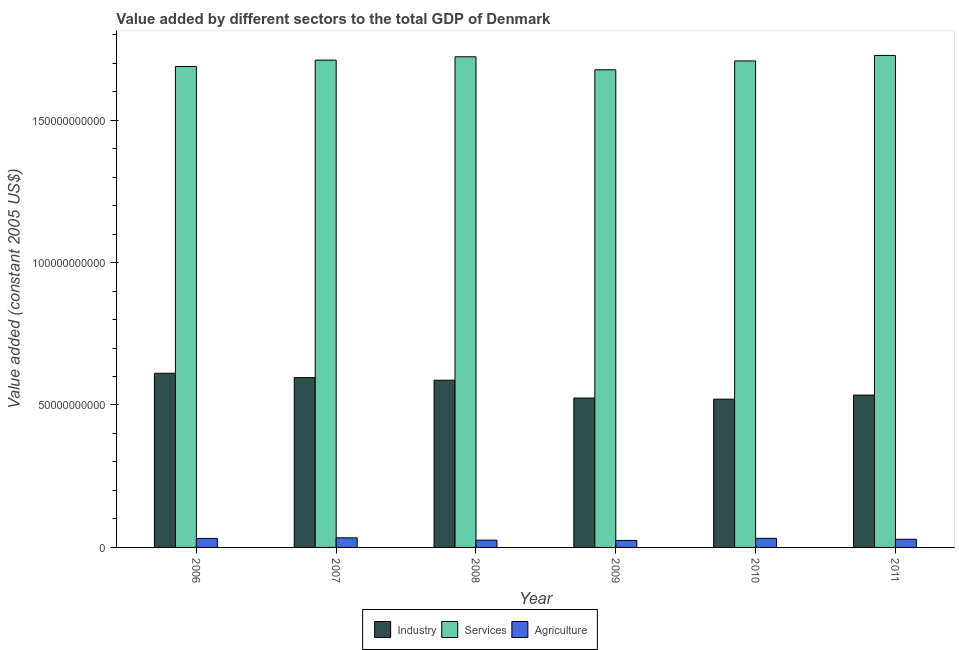How many different coloured bars are there?
Provide a short and direct response. 3. Are the number of bars per tick equal to the number of legend labels?
Offer a terse response. Yes. Are the number of bars on each tick of the X-axis equal?
Your answer should be very brief. Yes. How many bars are there on the 6th tick from the left?
Offer a terse response. 3. How many bars are there on the 6th tick from the right?
Keep it short and to the point. 3. What is the label of the 2nd group of bars from the left?
Make the answer very short. 2007. What is the value added by agricultural sector in 2011?
Keep it short and to the point. 2.87e+09. Across all years, what is the maximum value added by industrial sector?
Offer a terse response. 6.11e+1. Across all years, what is the minimum value added by services?
Offer a very short reply. 1.68e+11. In which year was the value added by industrial sector maximum?
Your response must be concise. 2006. What is the total value added by services in the graph?
Your answer should be compact. 1.02e+12. What is the difference between the value added by services in 2008 and that in 2010?
Give a very brief answer. 1.45e+09. What is the difference between the value added by services in 2007 and the value added by industrial sector in 2011?
Keep it short and to the point. -1.65e+09. What is the average value added by services per year?
Provide a short and direct response. 1.71e+11. In the year 2006, what is the difference between the value added by services and value added by agricultural sector?
Keep it short and to the point. 0. What is the ratio of the value added by industrial sector in 2009 to that in 2011?
Give a very brief answer. 0.98. What is the difference between the highest and the second highest value added by industrial sector?
Offer a very short reply. 1.52e+09. What is the difference between the highest and the lowest value added by industrial sector?
Offer a terse response. 9.08e+09. Is the sum of the value added by industrial sector in 2006 and 2007 greater than the maximum value added by services across all years?
Your answer should be compact. Yes. What does the 1st bar from the left in 2008 represents?
Ensure brevity in your answer.  Industry. What does the 1st bar from the right in 2007 represents?
Offer a very short reply. Agriculture. Are the values on the major ticks of Y-axis written in scientific E-notation?
Offer a terse response. No. Where does the legend appear in the graph?
Your answer should be compact. Bottom center. How many legend labels are there?
Your answer should be compact. 3. What is the title of the graph?
Provide a short and direct response. Value added by different sectors to the total GDP of Denmark. What is the label or title of the X-axis?
Provide a succinct answer. Year. What is the label or title of the Y-axis?
Keep it short and to the point. Value added (constant 2005 US$). What is the Value added (constant 2005 US$) of Industry in 2006?
Ensure brevity in your answer.  6.11e+1. What is the Value added (constant 2005 US$) of Services in 2006?
Give a very brief answer. 1.69e+11. What is the Value added (constant 2005 US$) of Agriculture in 2006?
Offer a very short reply. 3.16e+09. What is the Value added (constant 2005 US$) in Industry in 2007?
Keep it short and to the point. 5.96e+1. What is the Value added (constant 2005 US$) in Services in 2007?
Make the answer very short. 1.71e+11. What is the Value added (constant 2005 US$) of Agriculture in 2007?
Offer a terse response. 3.37e+09. What is the Value added (constant 2005 US$) of Industry in 2008?
Keep it short and to the point. 5.87e+1. What is the Value added (constant 2005 US$) in Services in 2008?
Your response must be concise. 1.72e+11. What is the Value added (constant 2005 US$) of Agriculture in 2008?
Give a very brief answer. 2.54e+09. What is the Value added (constant 2005 US$) in Industry in 2009?
Give a very brief answer. 5.24e+1. What is the Value added (constant 2005 US$) of Services in 2009?
Keep it short and to the point. 1.68e+11. What is the Value added (constant 2005 US$) in Agriculture in 2009?
Ensure brevity in your answer.  2.46e+09. What is the Value added (constant 2005 US$) of Industry in 2010?
Your answer should be compact. 5.21e+1. What is the Value added (constant 2005 US$) in Services in 2010?
Offer a terse response. 1.71e+11. What is the Value added (constant 2005 US$) in Agriculture in 2010?
Provide a short and direct response. 3.20e+09. What is the Value added (constant 2005 US$) of Industry in 2011?
Your answer should be compact. 5.35e+1. What is the Value added (constant 2005 US$) in Services in 2011?
Ensure brevity in your answer.  1.73e+11. What is the Value added (constant 2005 US$) of Agriculture in 2011?
Offer a terse response. 2.87e+09. Across all years, what is the maximum Value added (constant 2005 US$) of Industry?
Your answer should be compact. 6.11e+1. Across all years, what is the maximum Value added (constant 2005 US$) of Services?
Provide a short and direct response. 1.73e+11. Across all years, what is the maximum Value added (constant 2005 US$) in Agriculture?
Ensure brevity in your answer.  3.37e+09. Across all years, what is the minimum Value added (constant 2005 US$) in Industry?
Provide a succinct answer. 5.21e+1. Across all years, what is the minimum Value added (constant 2005 US$) of Services?
Ensure brevity in your answer.  1.68e+11. Across all years, what is the minimum Value added (constant 2005 US$) in Agriculture?
Your answer should be very brief. 2.46e+09. What is the total Value added (constant 2005 US$) of Industry in the graph?
Ensure brevity in your answer.  3.37e+11. What is the total Value added (constant 2005 US$) of Services in the graph?
Your answer should be very brief. 1.02e+12. What is the total Value added (constant 2005 US$) of Agriculture in the graph?
Offer a very short reply. 1.76e+1. What is the difference between the Value added (constant 2005 US$) in Industry in 2006 and that in 2007?
Your answer should be very brief. 1.52e+09. What is the difference between the Value added (constant 2005 US$) in Services in 2006 and that in 2007?
Make the answer very short. -2.23e+09. What is the difference between the Value added (constant 2005 US$) in Agriculture in 2006 and that in 2007?
Provide a succinct answer. -2.03e+08. What is the difference between the Value added (constant 2005 US$) in Industry in 2006 and that in 2008?
Your response must be concise. 2.44e+09. What is the difference between the Value added (constant 2005 US$) in Services in 2006 and that in 2008?
Your response must be concise. -3.40e+09. What is the difference between the Value added (constant 2005 US$) in Agriculture in 2006 and that in 2008?
Ensure brevity in your answer.  6.19e+08. What is the difference between the Value added (constant 2005 US$) of Industry in 2006 and that in 2009?
Your response must be concise. 8.69e+09. What is the difference between the Value added (constant 2005 US$) of Services in 2006 and that in 2009?
Your answer should be very brief. 1.16e+09. What is the difference between the Value added (constant 2005 US$) of Agriculture in 2006 and that in 2009?
Your answer should be very brief. 7.05e+08. What is the difference between the Value added (constant 2005 US$) of Industry in 2006 and that in 2010?
Keep it short and to the point. 9.08e+09. What is the difference between the Value added (constant 2005 US$) in Services in 2006 and that in 2010?
Your answer should be very brief. -1.96e+09. What is the difference between the Value added (constant 2005 US$) in Agriculture in 2006 and that in 2010?
Your answer should be very brief. -3.84e+07. What is the difference between the Value added (constant 2005 US$) of Industry in 2006 and that in 2011?
Offer a very short reply. 7.66e+09. What is the difference between the Value added (constant 2005 US$) in Services in 2006 and that in 2011?
Your answer should be very brief. -3.88e+09. What is the difference between the Value added (constant 2005 US$) of Agriculture in 2006 and that in 2011?
Keep it short and to the point. 2.90e+08. What is the difference between the Value added (constant 2005 US$) in Industry in 2007 and that in 2008?
Give a very brief answer. 9.13e+08. What is the difference between the Value added (constant 2005 US$) in Services in 2007 and that in 2008?
Your answer should be very brief. -1.17e+09. What is the difference between the Value added (constant 2005 US$) of Agriculture in 2007 and that in 2008?
Offer a very short reply. 8.22e+08. What is the difference between the Value added (constant 2005 US$) of Industry in 2007 and that in 2009?
Your answer should be compact. 7.17e+09. What is the difference between the Value added (constant 2005 US$) in Services in 2007 and that in 2009?
Provide a short and direct response. 3.39e+09. What is the difference between the Value added (constant 2005 US$) of Agriculture in 2007 and that in 2009?
Offer a very short reply. 9.08e+08. What is the difference between the Value added (constant 2005 US$) in Industry in 2007 and that in 2010?
Your answer should be very brief. 7.56e+09. What is the difference between the Value added (constant 2005 US$) of Services in 2007 and that in 2010?
Ensure brevity in your answer.  2.75e+08. What is the difference between the Value added (constant 2005 US$) in Agriculture in 2007 and that in 2010?
Your answer should be very brief. 1.65e+08. What is the difference between the Value added (constant 2005 US$) of Industry in 2007 and that in 2011?
Offer a terse response. 6.13e+09. What is the difference between the Value added (constant 2005 US$) of Services in 2007 and that in 2011?
Give a very brief answer. -1.65e+09. What is the difference between the Value added (constant 2005 US$) in Agriculture in 2007 and that in 2011?
Your answer should be very brief. 4.93e+08. What is the difference between the Value added (constant 2005 US$) of Industry in 2008 and that in 2009?
Offer a very short reply. 6.25e+09. What is the difference between the Value added (constant 2005 US$) of Services in 2008 and that in 2009?
Make the answer very short. 4.57e+09. What is the difference between the Value added (constant 2005 US$) in Agriculture in 2008 and that in 2009?
Provide a short and direct response. 8.63e+07. What is the difference between the Value added (constant 2005 US$) of Industry in 2008 and that in 2010?
Provide a succinct answer. 6.65e+09. What is the difference between the Value added (constant 2005 US$) in Services in 2008 and that in 2010?
Ensure brevity in your answer.  1.45e+09. What is the difference between the Value added (constant 2005 US$) of Agriculture in 2008 and that in 2010?
Offer a terse response. -6.57e+08. What is the difference between the Value added (constant 2005 US$) in Industry in 2008 and that in 2011?
Your response must be concise. 5.22e+09. What is the difference between the Value added (constant 2005 US$) of Services in 2008 and that in 2011?
Your response must be concise. -4.80e+08. What is the difference between the Value added (constant 2005 US$) of Agriculture in 2008 and that in 2011?
Offer a very short reply. -3.29e+08. What is the difference between the Value added (constant 2005 US$) of Industry in 2009 and that in 2010?
Your response must be concise. 3.93e+08. What is the difference between the Value added (constant 2005 US$) in Services in 2009 and that in 2010?
Your response must be concise. -3.12e+09. What is the difference between the Value added (constant 2005 US$) in Agriculture in 2009 and that in 2010?
Your answer should be compact. -7.44e+08. What is the difference between the Value added (constant 2005 US$) in Industry in 2009 and that in 2011?
Provide a succinct answer. -1.04e+09. What is the difference between the Value added (constant 2005 US$) of Services in 2009 and that in 2011?
Ensure brevity in your answer.  -5.04e+09. What is the difference between the Value added (constant 2005 US$) in Agriculture in 2009 and that in 2011?
Give a very brief answer. -4.15e+08. What is the difference between the Value added (constant 2005 US$) in Industry in 2010 and that in 2011?
Offer a terse response. -1.43e+09. What is the difference between the Value added (constant 2005 US$) in Services in 2010 and that in 2011?
Give a very brief answer. -1.93e+09. What is the difference between the Value added (constant 2005 US$) in Agriculture in 2010 and that in 2011?
Your answer should be compact. 3.29e+08. What is the difference between the Value added (constant 2005 US$) of Industry in 2006 and the Value added (constant 2005 US$) of Services in 2007?
Provide a short and direct response. -1.10e+11. What is the difference between the Value added (constant 2005 US$) in Industry in 2006 and the Value added (constant 2005 US$) in Agriculture in 2007?
Offer a terse response. 5.78e+1. What is the difference between the Value added (constant 2005 US$) of Services in 2006 and the Value added (constant 2005 US$) of Agriculture in 2007?
Your response must be concise. 1.65e+11. What is the difference between the Value added (constant 2005 US$) in Industry in 2006 and the Value added (constant 2005 US$) in Services in 2008?
Make the answer very short. -1.11e+11. What is the difference between the Value added (constant 2005 US$) in Industry in 2006 and the Value added (constant 2005 US$) in Agriculture in 2008?
Provide a succinct answer. 5.86e+1. What is the difference between the Value added (constant 2005 US$) of Services in 2006 and the Value added (constant 2005 US$) of Agriculture in 2008?
Your answer should be compact. 1.66e+11. What is the difference between the Value added (constant 2005 US$) of Industry in 2006 and the Value added (constant 2005 US$) of Services in 2009?
Your answer should be very brief. -1.07e+11. What is the difference between the Value added (constant 2005 US$) in Industry in 2006 and the Value added (constant 2005 US$) in Agriculture in 2009?
Give a very brief answer. 5.87e+1. What is the difference between the Value added (constant 2005 US$) of Services in 2006 and the Value added (constant 2005 US$) of Agriculture in 2009?
Provide a succinct answer. 1.66e+11. What is the difference between the Value added (constant 2005 US$) in Industry in 2006 and the Value added (constant 2005 US$) in Services in 2010?
Make the answer very short. -1.10e+11. What is the difference between the Value added (constant 2005 US$) of Industry in 2006 and the Value added (constant 2005 US$) of Agriculture in 2010?
Provide a short and direct response. 5.79e+1. What is the difference between the Value added (constant 2005 US$) of Services in 2006 and the Value added (constant 2005 US$) of Agriculture in 2010?
Provide a short and direct response. 1.66e+11. What is the difference between the Value added (constant 2005 US$) in Industry in 2006 and the Value added (constant 2005 US$) in Services in 2011?
Your response must be concise. -1.12e+11. What is the difference between the Value added (constant 2005 US$) in Industry in 2006 and the Value added (constant 2005 US$) in Agriculture in 2011?
Provide a succinct answer. 5.83e+1. What is the difference between the Value added (constant 2005 US$) of Services in 2006 and the Value added (constant 2005 US$) of Agriculture in 2011?
Make the answer very short. 1.66e+11. What is the difference between the Value added (constant 2005 US$) in Industry in 2007 and the Value added (constant 2005 US$) in Services in 2008?
Offer a terse response. -1.13e+11. What is the difference between the Value added (constant 2005 US$) in Industry in 2007 and the Value added (constant 2005 US$) in Agriculture in 2008?
Your answer should be very brief. 5.71e+1. What is the difference between the Value added (constant 2005 US$) of Services in 2007 and the Value added (constant 2005 US$) of Agriculture in 2008?
Ensure brevity in your answer.  1.69e+11. What is the difference between the Value added (constant 2005 US$) in Industry in 2007 and the Value added (constant 2005 US$) in Services in 2009?
Provide a short and direct response. -1.08e+11. What is the difference between the Value added (constant 2005 US$) of Industry in 2007 and the Value added (constant 2005 US$) of Agriculture in 2009?
Provide a succinct answer. 5.72e+1. What is the difference between the Value added (constant 2005 US$) of Services in 2007 and the Value added (constant 2005 US$) of Agriculture in 2009?
Give a very brief answer. 1.69e+11. What is the difference between the Value added (constant 2005 US$) of Industry in 2007 and the Value added (constant 2005 US$) of Services in 2010?
Your answer should be very brief. -1.11e+11. What is the difference between the Value added (constant 2005 US$) of Industry in 2007 and the Value added (constant 2005 US$) of Agriculture in 2010?
Make the answer very short. 5.64e+1. What is the difference between the Value added (constant 2005 US$) of Services in 2007 and the Value added (constant 2005 US$) of Agriculture in 2010?
Your response must be concise. 1.68e+11. What is the difference between the Value added (constant 2005 US$) in Industry in 2007 and the Value added (constant 2005 US$) in Services in 2011?
Keep it short and to the point. -1.13e+11. What is the difference between the Value added (constant 2005 US$) in Industry in 2007 and the Value added (constant 2005 US$) in Agriculture in 2011?
Your answer should be compact. 5.67e+1. What is the difference between the Value added (constant 2005 US$) of Services in 2007 and the Value added (constant 2005 US$) of Agriculture in 2011?
Give a very brief answer. 1.68e+11. What is the difference between the Value added (constant 2005 US$) in Industry in 2008 and the Value added (constant 2005 US$) in Services in 2009?
Keep it short and to the point. -1.09e+11. What is the difference between the Value added (constant 2005 US$) in Industry in 2008 and the Value added (constant 2005 US$) in Agriculture in 2009?
Make the answer very short. 5.62e+1. What is the difference between the Value added (constant 2005 US$) in Services in 2008 and the Value added (constant 2005 US$) in Agriculture in 2009?
Provide a short and direct response. 1.70e+11. What is the difference between the Value added (constant 2005 US$) of Industry in 2008 and the Value added (constant 2005 US$) of Services in 2010?
Your response must be concise. -1.12e+11. What is the difference between the Value added (constant 2005 US$) in Industry in 2008 and the Value added (constant 2005 US$) in Agriculture in 2010?
Make the answer very short. 5.55e+1. What is the difference between the Value added (constant 2005 US$) in Services in 2008 and the Value added (constant 2005 US$) in Agriculture in 2010?
Provide a short and direct response. 1.69e+11. What is the difference between the Value added (constant 2005 US$) in Industry in 2008 and the Value added (constant 2005 US$) in Services in 2011?
Provide a succinct answer. -1.14e+11. What is the difference between the Value added (constant 2005 US$) of Industry in 2008 and the Value added (constant 2005 US$) of Agriculture in 2011?
Keep it short and to the point. 5.58e+1. What is the difference between the Value added (constant 2005 US$) of Services in 2008 and the Value added (constant 2005 US$) of Agriculture in 2011?
Your answer should be compact. 1.69e+11. What is the difference between the Value added (constant 2005 US$) of Industry in 2009 and the Value added (constant 2005 US$) of Services in 2010?
Your answer should be very brief. -1.18e+11. What is the difference between the Value added (constant 2005 US$) in Industry in 2009 and the Value added (constant 2005 US$) in Agriculture in 2010?
Your answer should be compact. 4.92e+1. What is the difference between the Value added (constant 2005 US$) in Services in 2009 and the Value added (constant 2005 US$) in Agriculture in 2010?
Provide a short and direct response. 1.64e+11. What is the difference between the Value added (constant 2005 US$) in Industry in 2009 and the Value added (constant 2005 US$) in Services in 2011?
Give a very brief answer. -1.20e+11. What is the difference between the Value added (constant 2005 US$) of Industry in 2009 and the Value added (constant 2005 US$) of Agriculture in 2011?
Your answer should be compact. 4.96e+1. What is the difference between the Value added (constant 2005 US$) in Services in 2009 and the Value added (constant 2005 US$) in Agriculture in 2011?
Give a very brief answer. 1.65e+11. What is the difference between the Value added (constant 2005 US$) of Industry in 2010 and the Value added (constant 2005 US$) of Services in 2011?
Give a very brief answer. -1.21e+11. What is the difference between the Value added (constant 2005 US$) of Industry in 2010 and the Value added (constant 2005 US$) of Agriculture in 2011?
Provide a short and direct response. 4.92e+1. What is the difference between the Value added (constant 2005 US$) in Services in 2010 and the Value added (constant 2005 US$) in Agriculture in 2011?
Ensure brevity in your answer.  1.68e+11. What is the average Value added (constant 2005 US$) in Industry per year?
Provide a succinct answer. 5.62e+1. What is the average Value added (constant 2005 US$) of Services per year?
Your response must be concise. 1.71e+11. What is the average Value added (constant 2005 US$) of Agriculture per year?
Give a very brief answer. 2.93e+09. In the year 2006, what is the difference between the Value added (constant 2005 US$) of Industry and Value added (constant 2005 US$) of Services?
Provide a short and direct response. -1.08e+11. In the year 2006, what is the difference between the Value added (constant 2005 US$) in Industry and Value added (constant 2005 US$) in Agriculture?
Provide a short and direct response. 5.80e+1. In the year 2006, what is the difference between the Value added (constant 2005 US$) in Services and Value added (constant 2005 US$) in Agriculture?
Your answer should be compact. 1.66e+11. In the year 2007, what is the difference between the Value added (constant 2005 US$) in Industry and Value added (constant 2005 US$) in Services?
Make the answer very short. -1.11e+11. In the year 2007, what is the difference between the Value added (constant 2005 US$) of Industry and Value added (constant 2005 US$) of Agriculture?
Your answer should be very brief. 5.62e+1. In the year 2007, what is the difference between the Value added (constant 2005 US$) of Services and Value added (constant 2005 US$) of Agriculture?
Offer a very short reply. 1.68e+11. In the year 2008, what is the difference between the Value added (constant 2005 US$) in Industry and Value added (constant 2005 US$) in Services?
Make the answer very short. -1.14e+11. In the year 2008, what is the difference between the Value added (constant 2005 US$) of Industry and Value added (constant 2005 US$) of Agriculture?
Provide a succinct answer. 5.62e+1. In the year 2008, what is the difference between the Value added (constant 2005 US$) of Services and Value added (constant 2005 US$) of Agriculture?
Provide a short and direct response. 1.70e+11. In the year 2009, what is the difference between the Value added (constant 2005 US$) in Industry and Value added (constant 2005 US$) in Services?
Your answer should be compact. -1.15e+11. In the year 2009, what is the difference between the Value added (constant 2005 US$) of Industry and Value added (constant 2005 US$) of Agriculture?
Offer a very short reply. 5.00e+1. In the year 2009, what is the difference between the Value added (constant 2005 US$) in Services and Value added (constant 2005 US$) in Agriculture?
Your answer should be very brief. 1.65e+11. In the year 2010, what is the difference between the Value added (constant 2005 US$) of Industry and Value added (constant 2005 US$) of Services?
Ensure brevity in your answer.  -1.19e+11. In the year 2010, what is the difference between the Value added (constant 2005 US$) of Industry and Value added (constant 2005 US$) of Agriculture?
Your answer should be very brief. 4.89e+1. In the year 2010, what is the difference between the Value added (constant 2005 US$) of Services and Value added (constant 2005 US$) of Agriculture?
Offer a very short reply. 1.68e+11. In the year 2011, what is the difference between the Value added (constant 2005 US$) of Industry and Value added (constant 2005 US$) of Services?
Provide a short and direct response. -1.19e+11. In the year 2011, what is the difference between the Value added (constant 2005 US$) in Industry and Value added (constant 2005 US$) in Agriculture?
Ensure brevity in your answer.  5.06e+1. In the year 2011, what is the difference between the Value added (constant 2005 US$) of Services and Value added (constant 2005 US$) of Agriculture?
Your response must be concise. 1.70e+11. What is the ratio of the Value added (constant 2005 US$) of Industry in 2006 to that in 2007?
Make the answer very short. 1.03. What is the ratio of the Value added (constant 2005 US$) of Agriculture in 2006 to that in 2007?
Ensure brevity in your answer.  0.94. What is the ratio of the Value added (constant 2005 US$) of Industry in 2006 to that in 2008?
Make the answer very short. 1.04. What is the ratio of the Value added (constant 2005 US$) of Services in 2006 to that in 2008?
Your response must be concise. 0.98. What is the ratio of the Value added (constant 2005 US$) in Agriculture in 2006 to that in 2008?
Your answer should be very brief. 1.24. What is the ratio of the Value added (constant 2005 US$) in Industry in 2006 to that in 2009?
Offer a terse response. 1.17. What is the ratio of the Value added (constant 2005 US$) in Agriculture in 2006 to that in 2009?
Ensure brevity in your answer.  1.29. What is the ratio of the Value added (constant 2005 US$) in Industry in 2006 to that in 2010?
Your answer should be very brief. 1.17. What is the ratio of the Value added (constant 2005 US$) of Services in 2006 to that in 2010?
Provide a succinct answer. 0.99. What is the ratio of the Value added (constant 2005 US$) in Agriculture in 2006 to that in 2010?
Give a very brief answer. 0.99. What is the ratio of the Value added (constant 2005 US$) in Industry in 2006 to that in 2011?
Offer a very short reply. 1.14. What is the ratio of the Value added (constant 2005 US$) of Services in 2006 to that in 2011?
Offer a very short reply. 0.98. What is the ratio of the Value added (constant 2005 US$) of Agriculture in 2006 to that in 2011?
Offer a terse response. 1.1. What is the ratio of the Value added (constant 2005 US$) of Industry in 2007 to that in 2008?
Make the answer very short. 1.02. What is the ratio of the Value added (constant 2005 US$) of Services in 2007 to that in 2008?
Make the answer very short. 0.99. What is the ratio of the Value added (constant 2005 US$) in Agriculture in 2007 to that in 2008?
Your answer should be very brief. 1.32. What is the ratio of the Value added (constant 2005 US$) of Industry in 2007 to that in 2009?
Give a very brief answer. 1.14. What is the ratio of the Value added (constant 2005 US$) in Services in 2007 to that in 2009?
Make the answer very short. 1.02. What is the ratio of the Value added (constant 2005 US$) of Agriculture in 2007 to that in 2009?
Provide a short and direct response. 1.37. What is the ratio of the Value added (constant 2005 US$) in Industry in 2007 to that in 2010?
Your response must be concise. 1.15. What is the ratio of the Value added (constant 2005 US$) of Agriculture in 2007 to that in 2010?
Your answer should be compact. 1.05. What is the ratio of the Value added (constant 2005 US$) in Industry in 2007 to that in 2011?
Make the answer very short. 1.11. What is the ratio of the Value added (constant 2005 US$) in Agriculture in 2007 to that in 2011?
Give a very brief answer. 1.17. What is the ratio of the Value added (constant 2005 US$) of Industry in 2008 to that in 2009?
Your answer should be compact. 1.12. What is the ratio of the Value added (constant 2005 US$) of Services in 2008 to that in 2009?
Keep it short and to the point. 1.03. What is the ratio of the Value added (constant 2005 US$) in Agriculture in 2008 to that in 2009?
Offer a very short reply. 1.04. What is the ratio of the Value added (constant 2005 US$) in Industry in 2008 to that in 2010?
Provide a short and direct response. 1.13. What is the ratio of the Value added (constant 2005 US$) of Services in 2008 to that in 2010?
Make the answer very short. 1.01. What is the ratio of the Value added (constant 2005 US$) of Agriculture in 2008 to that in 2010?
Give a very brief answer. 0.79. What is the ratio of the Value added (constant 2005 US$) in Industry in 2008 to that in 2011?
Your response must be concise. 1.1. What is the ratio of the Value added (constant 2005 US$) in Agriculture in 2008 to that in 2011?
Make the answer very short. 0.89. What is the ratio of the Value added (constant 2005 US$) of Industry in 2009 to that in 2010?
Offer a terse response. 1.01. What is the ratio of the Value added (constant 2005 US$) of Services in 2009 to that in 2010?
Offer a terse response. 0.98. What is the ratio of the Value added (constant 2005 US$) in Agriculture in 2009 to that in 2010?
Give a very brief answer. 0.77. What is the ratio of the Value added (constant 2005 US$) in Industry in 2009 to that in 2011?
Ensure brevity in your answer.  0.98. What is the ratio of the Value added (constant 2005 US$) in Services in 2009 to that in 2011?
Your response must be concise. 0.97. What is the ratio of the Value added (constant 2005 US$) of Agriculture in 2009 to that in 2011?
Provide a succinct answer. 0.86. What is the ratio of the Value added (constant 2005 US$) in Industry in 2010 to that in 2011?
Provide a short and direct response. 0.97. What is the ratio of the Value added (constant 2005 US$) in Services in 2010 to that in 2011?
Your answer should be compact. 0.99. What is the ratio of the Value added (constant 2005 US$) in Agriculture in 2010 to that in 2011?
Make the answer very short. 1.11. What is the difference between the highest and the second highest Value added (constant 2005 US$) in Industry?
Your answer should be compact. 1.52e+09. What is the difference between the highest and the second highest Value added (constant 2005 US$) of Services?
Your answer should be very brief. 4.80e+08. What is the difference between the highest and the second highest Value added (constant 2005 US$) of Agriculture?
Make the answer very short. 1.65e+08. What is the difference between the highest and the lowest Value added (constant 2005 US$) of Industry?
Your answer should be very brief. 9.08e+09. What is the difference between the highest and the lowest Value added (constant 2005 US$) in Services?
Your answer should be very brief. 5.04e+09. What is the difference between the highest and the lowest Value added (constant 2005 US$) of Agriculture?
Keep it short and to the point. 9.08e+08. 